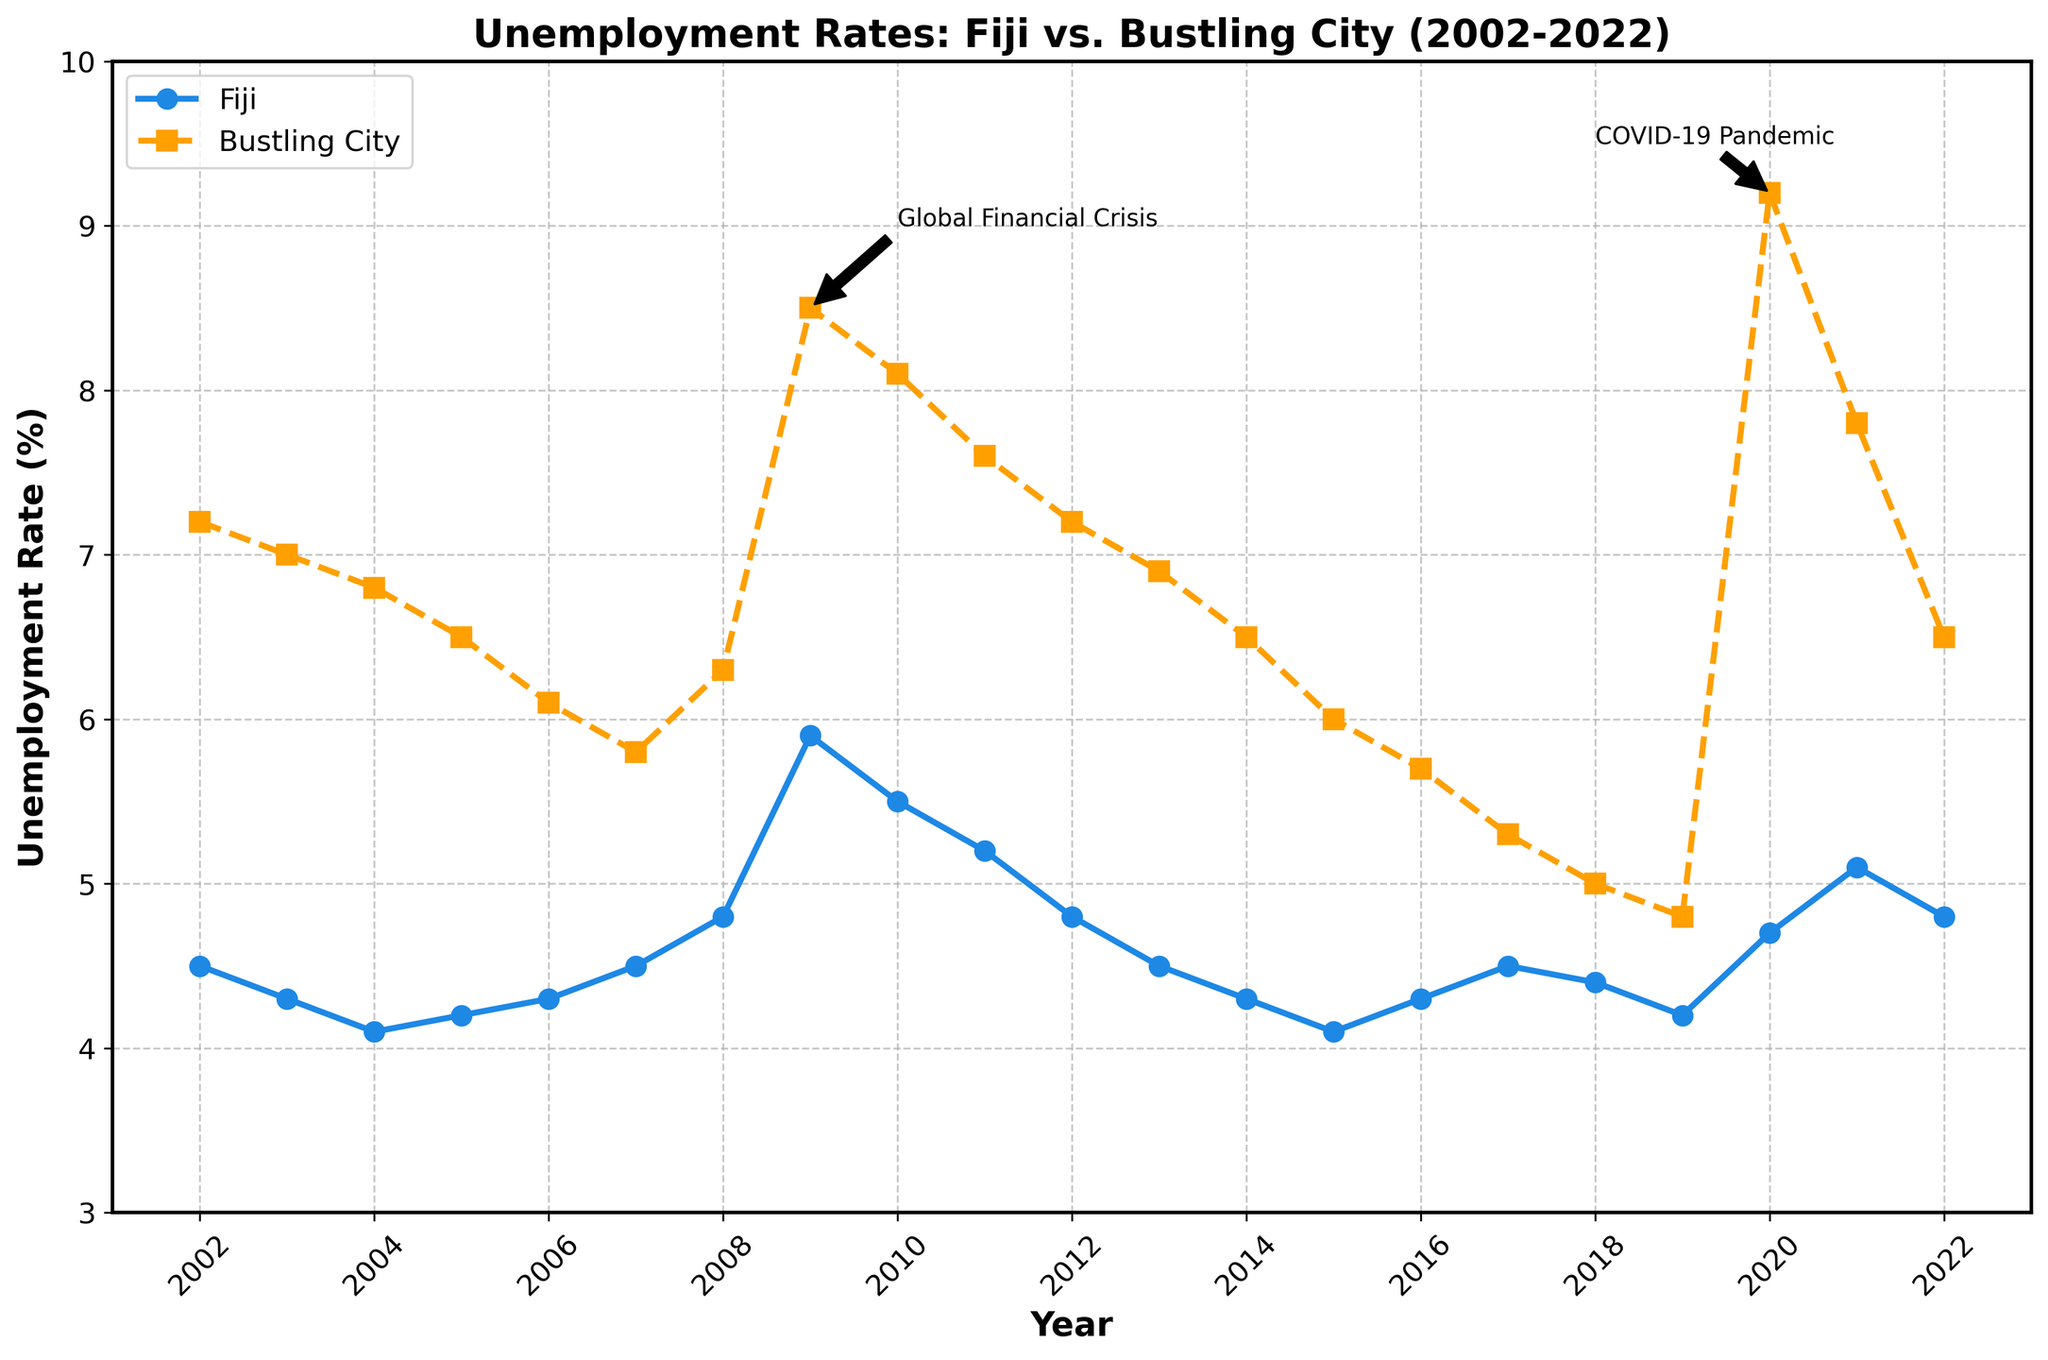What were the unemployment rates in Fiji and the bustling city in 2002? In 2002, the figure shows the unemployment rate in Fiji at 4.5% and in the bustling city at 7.2%.
Answer: Fiji: 4.5%, Bustling City: 7.2% Which year had the highest unemployment rate in Fiji, and what was the rate? According to the figure, the unemployment rate in Fiji peaked around 2009 at approximately 5.9%.
Answer: 2009: 5.9% How does the unemployment rate in the bustling city in 2020 compare to Fiji's rate in the same year? In 2020, the unemployment rate in the bustling city was 9.2%, significantly higher than Fiji's rate of 4.7%.
Answer: Bustling City: 9.2%, Fiji: 4.7% What trend is observed in the unemployment rates of the bustling city from 2008 to 2010? The bustling city's unemployment rates increased sharply from 6.3% in 2008 to 8.5% in 2009, then slightly decreased to 8.1% in 2010.
Answer: Increasing, then slightly decreasing During which period did both Fiji and the bustling city experience a notable rise in unemployment rates, and what can be inferred as a possible reason? Both regions saw a notable rise in unemployment rates around 2008-2009, likely due to the Global Financial Crisis, as indicated by an annotation on the figure.
Answer: 2008-2009, Global Financial Crisis Compare the general trend of unemployment rates between Fiji and the bustling city from 2016 to 2019. The figure shows a general decline in unemployment rates for both Fiji (from 4.3% to 4.2%) and the bustling city (from 5.7% to 4.8%) from 2016 to 2019.
Answer: Both have a declining trend What visual annotations are present in the figure, and what significant events do they label? The figure contains annotations for the 'Global Financial Crisis' around 2009, and the 'COVID-19 Pandemic' around 2020.
Answer: Global Financial Crisis, COVID-19 Pandemic By comparing the rates in 2009 and 2021, did the bustling city's unemployment rate recover more or less than Fiji's by 2021? In 2009, the bustling city had an 8.5% rate and by 2021 it was 7.8%, a reduction of 0.7%. For Fiji, the 2009 rate was 5.9% and 5.1% by 2021, a reduction of 0.8%. Fiji's rate showed a slightly better recovery.
Answer: Fiji recovered more Identify the year with the lowest unemployment rate in the bustling city and describe the trend leading up to that year. In 2019, the bustling city had its lowest rate at 4.8%; leading up to this, there was a consistent decline from 2014, where the rate was 6.5%.
Answer: 2019, decreasing trend 